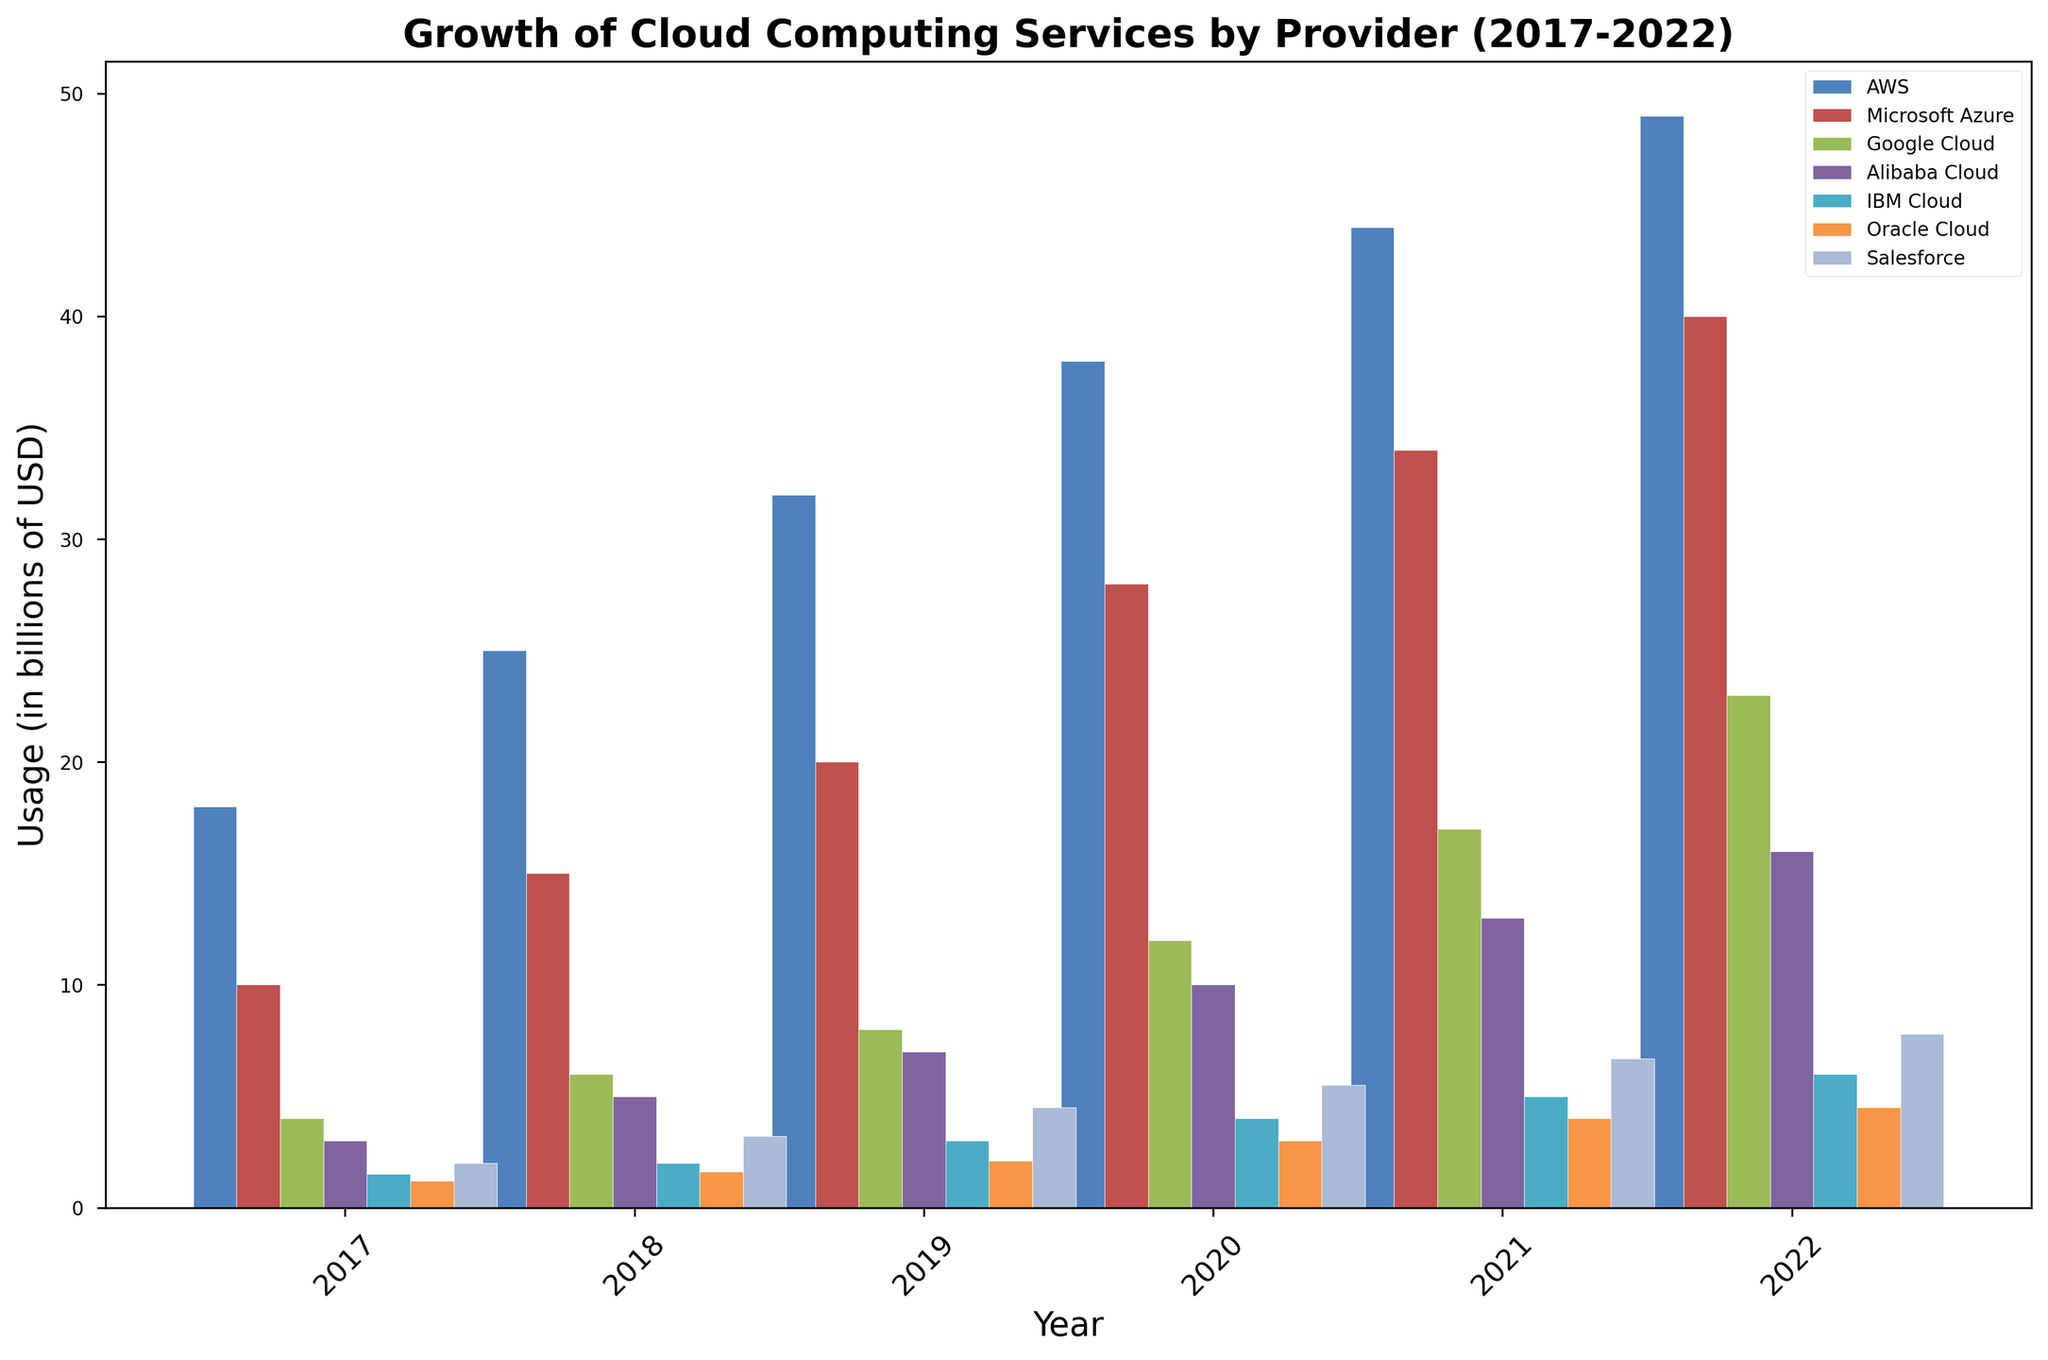What is the total combined usage (in billions of USD) of AWS and Google Cloud in 2022? First, find the usage of AWS in 2022 which is 49 billion USD. Next, find the usage of Google Cloud in 2022 which is 23 billion USD. Add these amounts together: 49 + 23 = 72 billion USD.
Answer: 72 Which provider had the highest usage in 2018? Look at the height of the bars for all providers in 2018. Identify the tallest bar, which corresponds to AWS with a usage of 25 billion USD.
Answer: AWS What is the growth in usage (in billions of USD) for Microsoft Azure between 2017 and 2022? Find the usage of Microsoft Azure in 2017 which is 10 billion USD and in 2022 which is 40 billion USD. Calculate the difference: 40 - 10 = 30 billion USD.
Answer: 30 Which provider had a lower usage in 2019, IBM Cloud or Oracle Cloud? Compare the heights of the bars for IBM Cloud and Oracle Cloud in 2019. IBM Cloud had a usage of 3 billion USD while Oracle Cloud had a usage of 2.1 billion USD, so Oracle Cloud had lower usage.
Answer: Oracle Cloud Which color represents Alibaba Cloud in the plot? Visually identify the bar color corresponding to Alibaba Cloud from the legend and the bars themselves. The bar color for Alibaba Cloud is a shade of green.
Answer: Green In which year did Salesforce see the largest increase in usage compared to the previous year? Compare the yearly increments for Salesforce by subtraction: 2018 (3.2 - 2 = 1.2), 2019 (4.5 - 3.2 = 1.3), 2020 (5.5 - 4.5 = 1), 2021 (6.7 - 5.5 = 1.2), and 2022 (7.8 - 6.7 = 1.1). The largest increase is from 2018 to 2019 with a 1.3 billion USD increase.
Answer: 2019 Which provider had the smallest total usage from 2017 to 2022? Sum the usage values for each provider across all years. IBM Cloud's total is 21.5 billion USD, which is the smallest sum.
Answer: IBM Cloud How did the usage of Alibaba Cloud change from 2018 to 2019, and by how much (in billions of USD)? Find the 2018 usage of Alibaba Cloud which is 5 billion USD and the 2019 usage which is 7 billion USD. Subtract 5 from 7 to find the change: 7 - 5 = 2 billion USD.
Answer: 2 